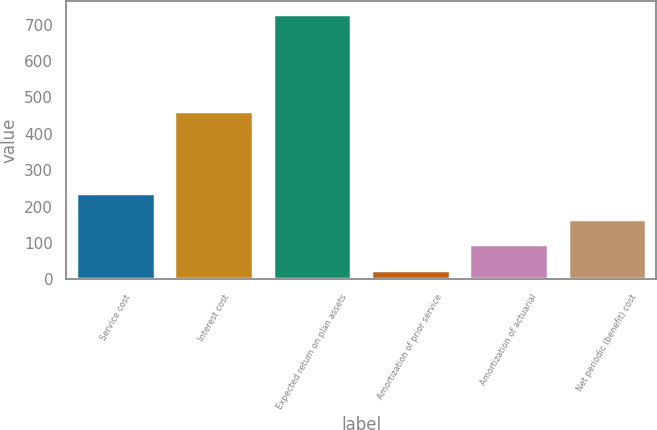<chart> <loc_0><loc_0><loc_500><loc_500><bar_chart><fcel>Service cost<fcel>Interest cost<fcel>Expected return on plan assets<fcel>Amortization of prior service<fcel>Amortization of actuarial<fcel>Net periodic (benefit) cost<nl><fcel>236.6<fcel>462<fcel>728<fcel>26<fcel>96.2<fcel>166.4<nl></chart> 